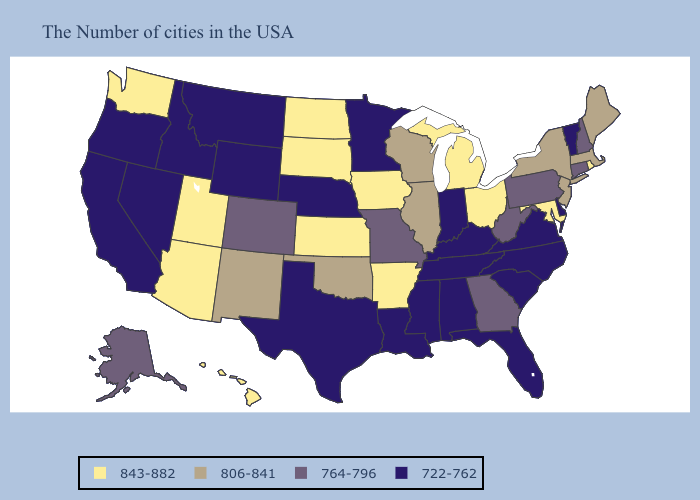What is the highest value in the West ?
Concise answer only. 843-882. Does Arkansas have a higher value than North Dakota?
Answer briefly. No. What is the highest value in the West ?
Keep it brief. 843-882. Name the states that have a value in the range 764-796?
Short answer required. New Hampshire, Connecticut, Pennsylvania, West Virginia, Georgia, Missouri, Colorado, Alaska. Does the first symbol in the legend represent the smallest category?
Be succinct. No. Name the states that have a value in the range 764-796?
Answer briefly. New Hampshire, Connecticut, Pennsylvania, West Virginia, Georgia, Missouri, Colorado, Alaska. What is the highest value in the South ?
Write a very short answer. 843-882. What is the lowest value in the South?
Keep it brief. 722-762. Which states hav the highest value in the Northeast?
Answer briefly. Rhode Island. Does California have the highest value in the West?
Quick response, please. No. Does Hawaii have the highest value in the USA?
Concise answer only. Yes. Among the states that border Oklahoma , does Kansas have the highest value?
Concise answer only. Yes. Name the states that have a value in the range 806-841?
Write a very short answer. Maine, Massachusetts, New York, New Jersey, Wisconsin, Illinois, Oklahoma, New Mexico. Among the states that border Florida , does Georgia have the lowest value?
Keep it brief. No. What is the value of Delaware?
Keep it brief. 722-762. 